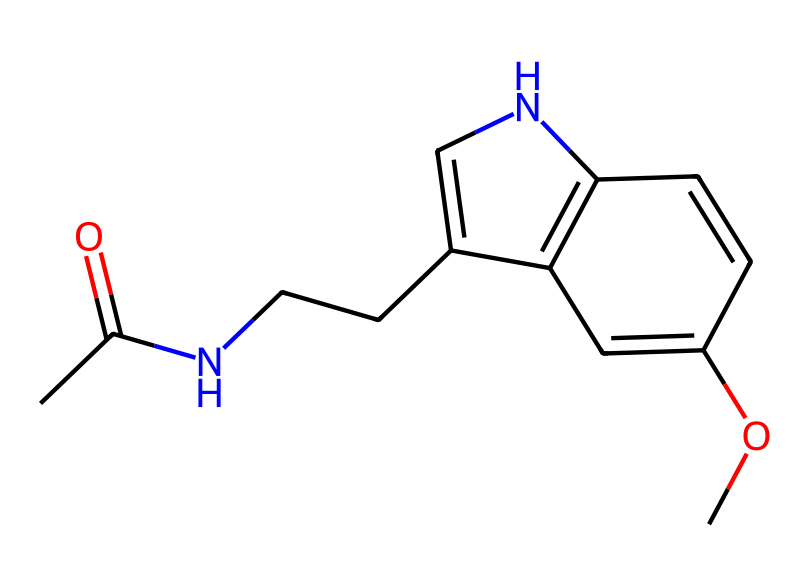What is the molecular formula of melatonin? To find the molecular formula, count the number of each type of atom in the SMILES representation. By analyzing CC(=O)NCCC1=CNC2=C1C=C(OC)C=C2, we identify 13 carbon (C), 16 hydrogen (H), 2 nitrogen (N), and 2 oxygen (O) atoms. Therefore, the molecular formula is C13H16N2O2.
Answer: C13H16N2O2 How many double bonds are present in the structure of melatonin? In the SMILES representation, look for the '=' sign which denotes double bonds. By examining the structure, we find there are four double bonds connecting various carbon atoms. Therefore, the total number of double bonds is four.
Answer: four What type of functional groups are present in melatonin? The SMILES notation indicates the presence of an acetamide group (CC(=O)N) due to the carbonyl (C=O) and nitrogen (N) indicating a type of amide. Additionally, the methoxy group (OC) is identified by the oxygen and carbon groups linked to an alkane segment. Hence, melatonin contains an acetamide and a methoxy functional group.
Answer: acetamide and methoxy What is the total number of nitrogen atoms in melatonin? From the SMILES notation, we can see that there are two occurrences of the nitrogen atom (N). Hence, the total number of nitrogen atoms is two.
Answer: two Why is melatonin classified as a non-electrolyte? A non-electrolyte is a substance that does not dissociate into ions in solution. Analyzing the structure, melatonin is a neutral molecule, meaning it does not contain free ions when dissolved in a solvent like water. Therefore, its molecular structure lacks ionic bonds which would lead to dissociation.
Answer: neutral molecule What aspect of melatonin's structure relates to its role in sleep regulation? The indole ring present in the structure, derived from its cyclic and aromatic system, is associated with biological activity, particularly in the synthesis of serotonin, which plays a critical role in regulating sleep patterns. The specific arrangement contributes to the signaling involved in sleep regulation.
Answer: indole ring 